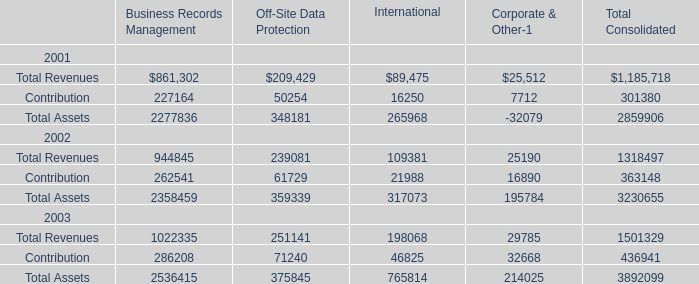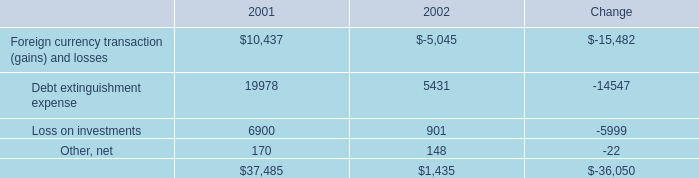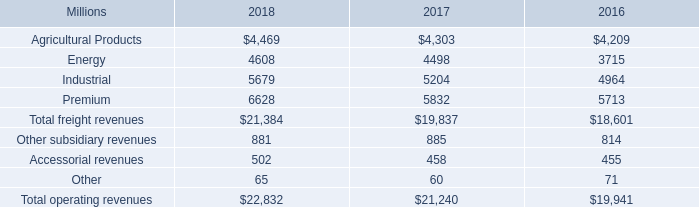What's the sum of all Business Records Management that are positive in 2001? 
Computations: ((861302 + 227164) + 2277836)
Answer: 3366302.0. 